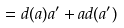Convert formula to latex. <formula><loc_0><loc_0><loc_500><loc_500>= { d ( a ) a ^ { \prime } + a d ( a ^ { \prime } ) }</formula> 